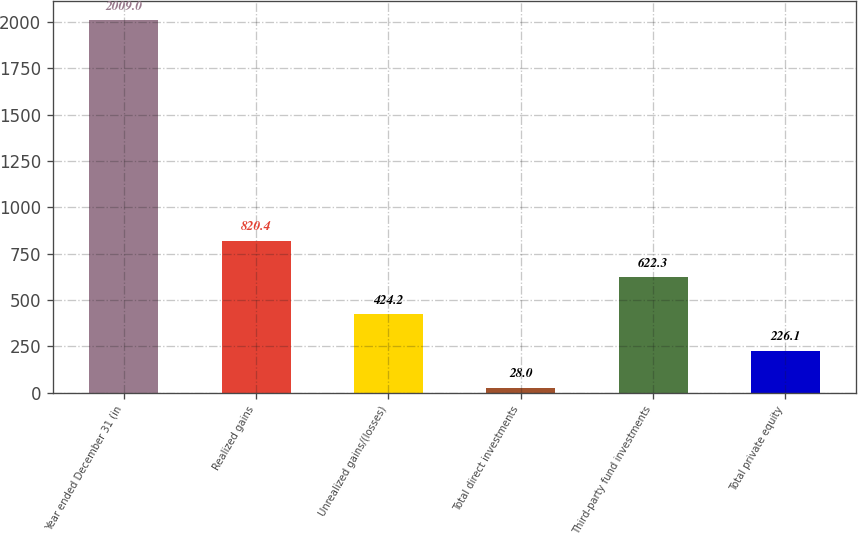Convert chart. <chart><loc_0><loc_0><loc_500><loc_500><bar_chart><fcel>Year ended December 31 (in<fcel>Realized gains<fcel>Unrealized gains/(losses)<fcel>Total direct investments<fcel>Third-party fund investments<fcel>Total private equity<nl><fcel>2009<fcel>820.4<fcel>424.2<fcel>28<fcel>622.3<fcel>226.1<nl></chart> 